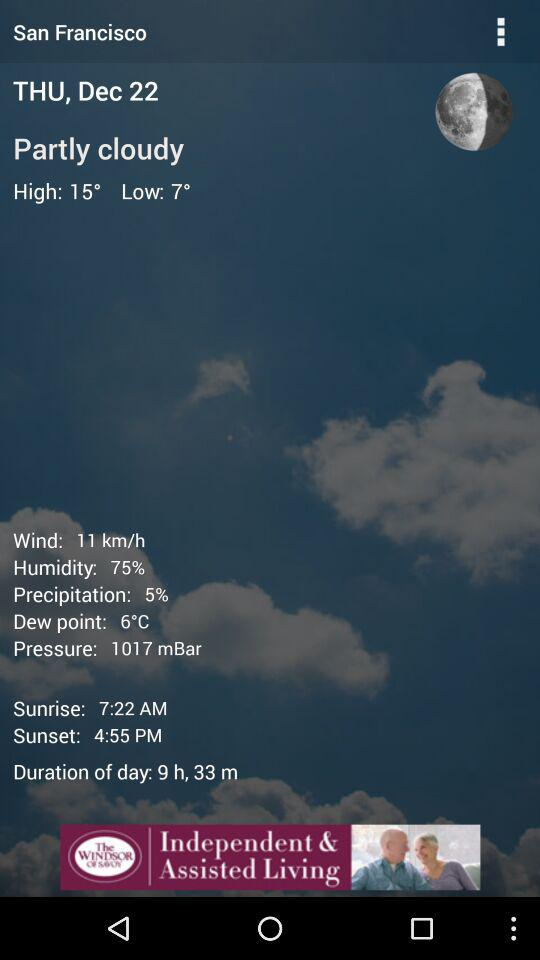How many hours and minutes is the duration of day?
Answer the question using a single word or phrase. 9 h, 33 m 